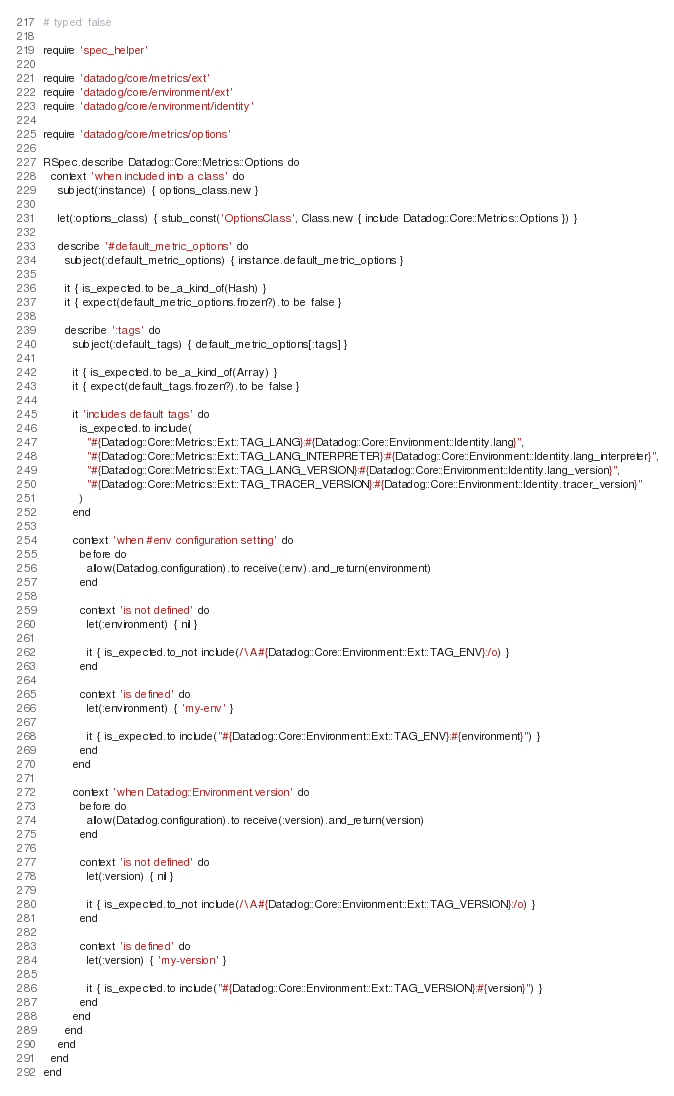<code> <loc_0><loc_0><loc_500><loc_500><_Ruby_># typed: false

require 'spec_helper'

require 'datadog/core/metrics/ext'
require 'datadog/core/environment/ext'
require 'datadog/core/environment/identity'

require 'datadog/core/metrics/options'

RSpec.describe Datadog::Core::Metrics::Options do
  context 'when included into a class' do
    subject(:instance) { options_class.new }

    let(:options_class) { stub_const('OptionsClass', Class.new { include Datadog::Core::Metrics::Options }) }

    describe '#default_metric_options' do
      subject(:default_metric_options) { instance.default_metric_options }

      it { is_expected.to be_a_kind_of(Hash) }
      it { expect(default_metric_options.frozen?).to be false }

      describe ':tags' do
        subject(:default_tags) { default_metric_options[:tags] }

        it { is_expected.to be_a_kind_of(Array) }
        it { expect(default_tags.frozen?).to be false }

        it 'includes default tags' do
          is_expected.to include(
            "#{Datadog::Core::Metrics::Ext::TAG_LANG}:#{Datadog::Core::Environment::Identity.lang}",
            "#{Datadog::Core::Metrics::Ext::TAG_LANG_INTERPRETER}:#{Datadog::Core::Environment::Identity.lang_interpreter}",
            "#{Datadog::Core::Metrics::Ext::TAG_LANG_VERSION}:#{Datadog::Core::Environment::Identity.lang_version}",
            "#{Datadog::Core::Metrics::Ext::TAG_TRACER_VERSION}:#{Datadog::Core::Environment::Identity.tracer_version}"
          )
        end

        context 'when #env configuration setting' do
          before do
            allow(Datadog.configuration).to receive(:env).and_return(environment)
          end

          context 'is not defined' do
            let(:environment) { nil }

            it { is_expected.to_not include(/\A#{Datadog::Core::Environment::Ext::TAG_ENV}:/o) }
          end

          context 'is defined' do
            let(:environment) { 'my-env' }

            it { is_expected.to include("#{Datadog::Core::Environment::Ext::TAG_ENV}:#{environment}") }
          end
        end

        context 'when Datadog::Environment.version' do
          before do
            allow(Datadog.configuration).to receive(:version).and_return(version)
          end

          context 'is not defined' do
            let(:version) { nil }

            it { is_expected.to_not include(/\A#{Datadog::Core::Environment::Ext::TAG_VERSION}:/o) }
          end

          context 'is defined' do
            let(:version) { 'my-version' }

            it { is_expected.to include("#{Datadog::Core::Environment::Ext::TAG_VERSION}:#{version}") }
          end
        end
      end
    end
  end
end
</code> 